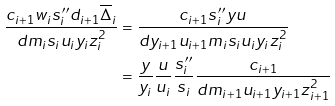Convert formula to latex. <formula><loc_0><loc_0><loc_500><loc_500>\frac { c _ { i + 1 } w _ { i } s _ { i } ^ { \prime \prime } d _ { i + 1 } \overline { \Delta } _ { i } } { d m _ { i } s _ { i } u _ { i } y _ { i } z _ { i } ^ { 2 } } & = \frac { c _ { i + 1 } s _ { i } ^ { \prime \prime } y u } { d y _ { i + 1 } u _ { i + 1 } m _ { i } s _ { i } u _ { i } y _ { i } z _ { i } ^ { 2 } } \\ & = \frac { y } { y _ { i } } \frac { u } { u _ { i } } \frac { s _ { i } ^ { \prime \prime } } { s _ { i } } \frac { c _ { i + 1 } } { d m _ { i + 1 } u _ { i + 1 } y _ { i + 1 } z _ { i + 1 } ^ { 2 } }</formula> 